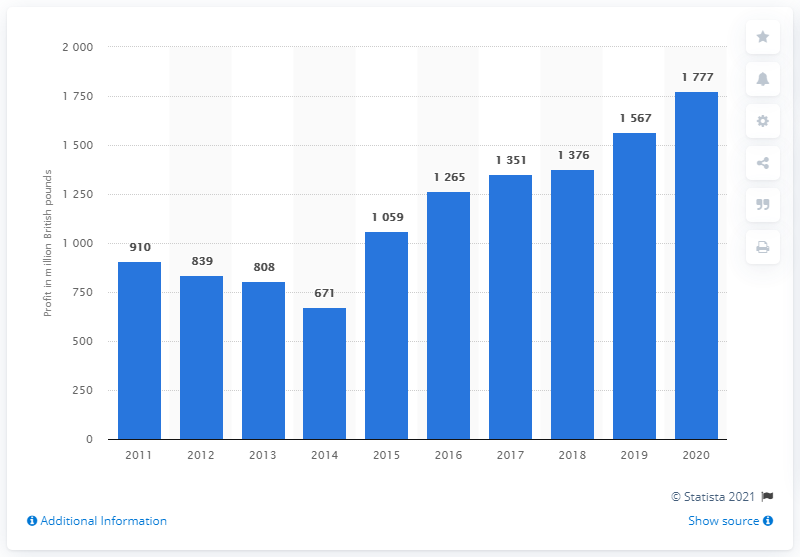Identify some key points in this picture. In 2020, GlaxoSmithKline spent a total of 1,777 on advertising. 